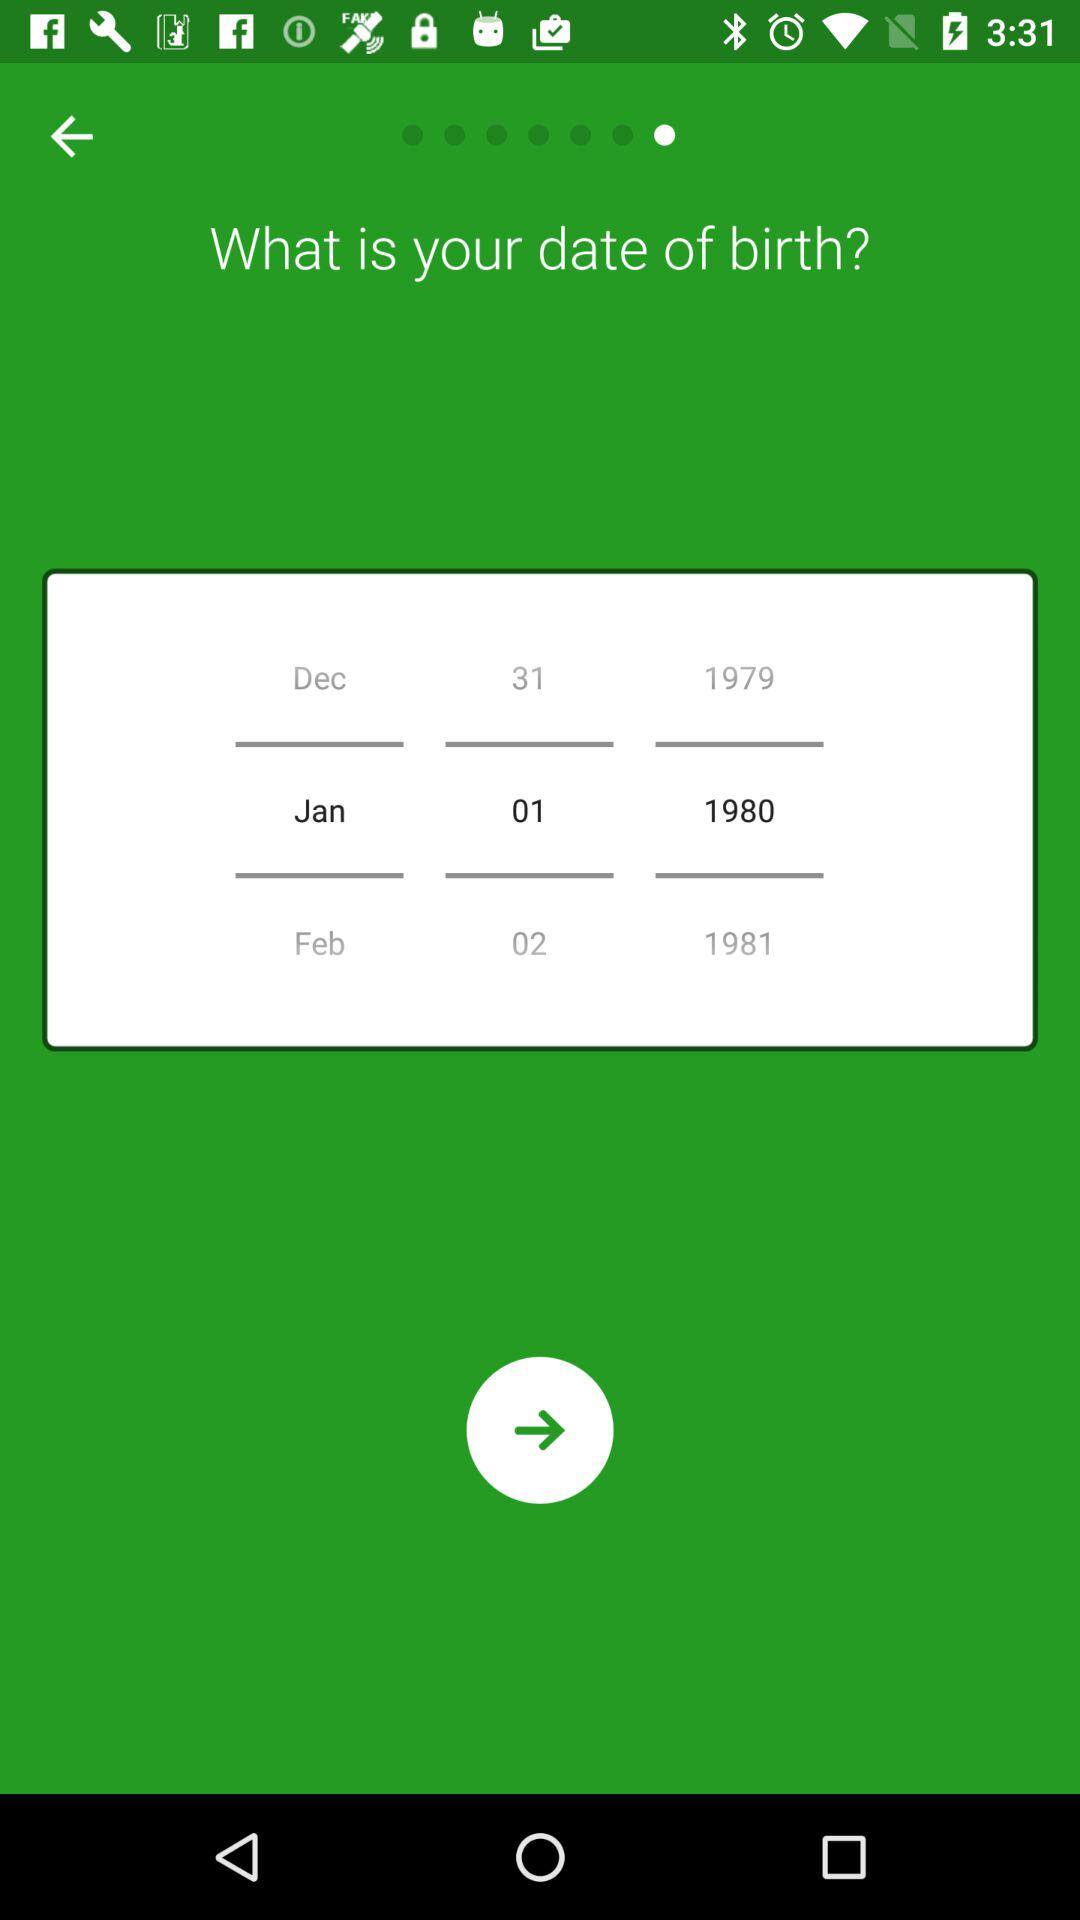Which day of the week falls on January 1, 1980?
When the provided information is insufficient, respond with <no answer>. <no answer> 